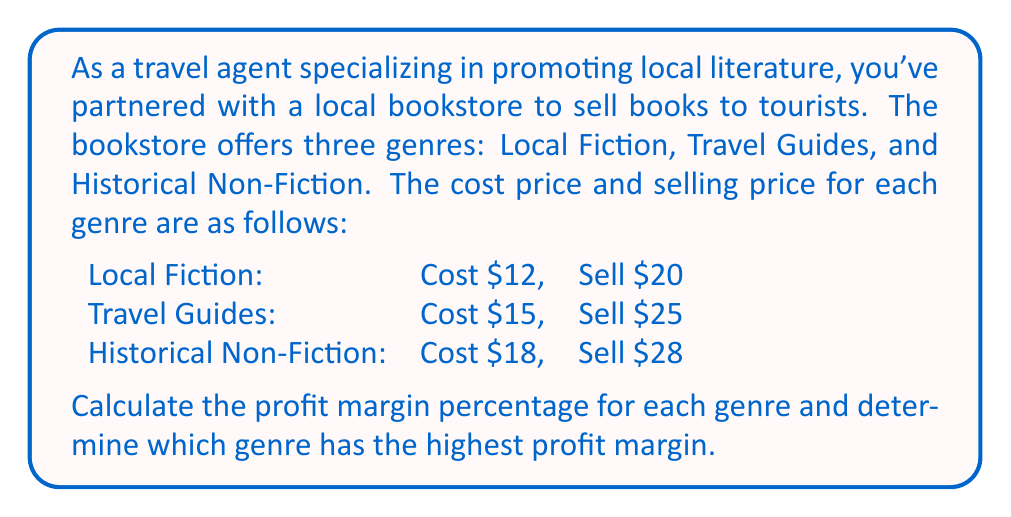Give your solution to this math problem. To solve this problem, we need to follow these steps:

1. Calculate the profit for each genre
2. Calculate the profit margin percentage for each genre
3. Compare the profit margin percentages

Step 1: Calculate the profit for each genre
Profit = Selling Price - Cost Price

Local Fiction: $20 - $12 = $8
Travel Guides: $25 - $15 = $10
Historical Non-Fiction: $28 - $18 = $10

Step 2: Calculate the profit margin percentage for each genre
Profit Margin % = (Profit / Selling Price) × 100

Local Fiction: 
$$ \text{Profit Margin} = \frac{8}{20} \times 100 = 40\% $$

Travel Guides:
$$ \text{Profit Margin} = \frac{10}{25} \times 100 = 40\% $$

Historical Non-Fiction:
$$ \text{Profit Margin} = \frac{10}{28} \times 100 \approx 35.71\% $$

Step 3: Compare the profit margin percentages
Local Fiction: 40%
Travel Guides: 40%
Historical Non-Fiction: 35.71%

We can see that Local Fiction and Travel Guides have the highest profit margin at 40%.
Answer: The profit margin percentages are:
Local Fiction: 40%
Travel Guides: 40%
Historical Non-Fiction: 35.71%

Local Fiction and Travel Guides have the highest profit margin at 40%. 